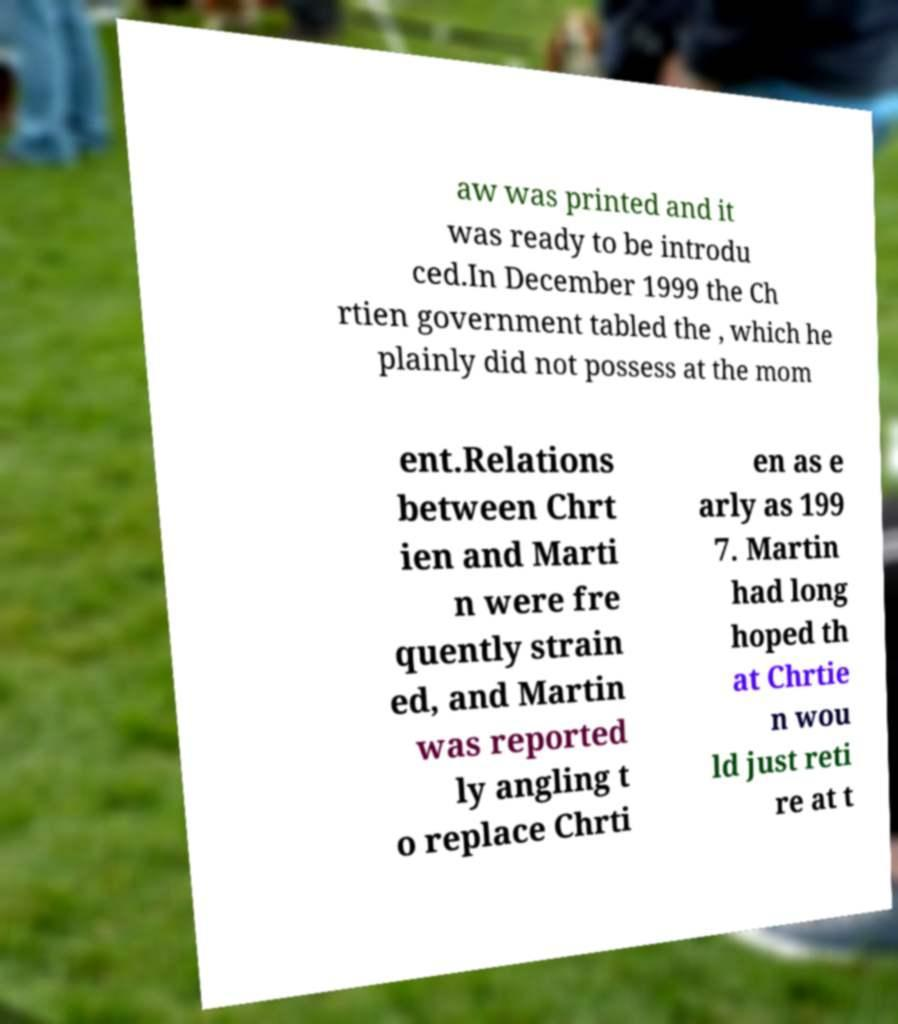Please read and relay the text visible in this image. What does it say? aw was printed and it was ready to be introdu ced.In December 1999 the Ch rtien government tabled the , which he plainly did not possess at the mom ent.Relations between Chrt ien and Marti n were fre quently strain ed, and Martin was reported ly angling t o replace Chrti en as e arly as 199 7. Martin had long hoped th at Chrtie n wou ld just reti re at t 